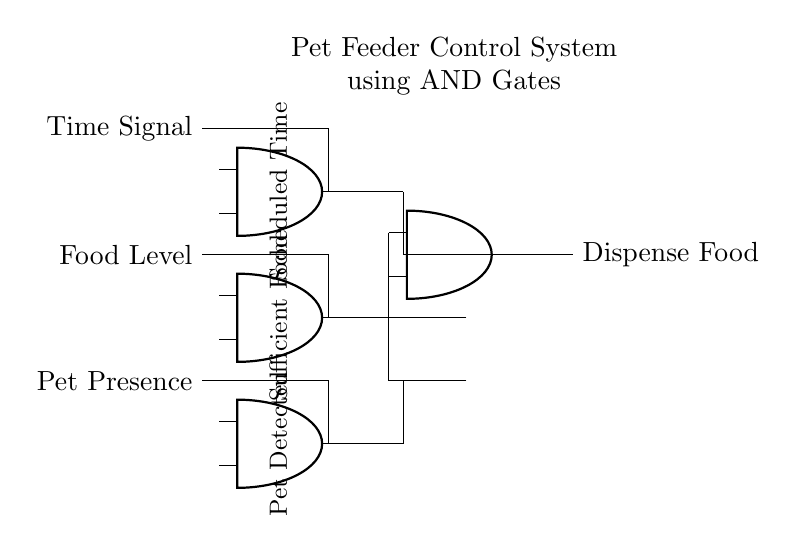What are the inputs to the first AND gate? The inputs to the first AND gate are the "Time Signal" and the "Food Level." It shows that both conditions must be met for the first AND gate to provide an output.
Answer: Time Signal, Food Level What does the final AND gate output trigger? The final AND gate outputs trigger the "Dispense Food" action when all its inputs are satisfied. Each preceding condition must be fulfilled for food to be dispensed.
Answer: Dispense Food How many AND gates are in this circuit? The circuit contains four AND gates: three input gates and one final gate that aggregates their outputs. This setup allows complex conditions to be evaluated.
Answer: Four What three conditions must be true to dispense food? The three conditions that must be true are "Scheduled Time," "Sufficient Food," and "Pet Detected." All conditions must be true to ensure the feeding action occurs.
Answer: Scheduled Time, Sufficient Food, Pet Detected What happens if one of the inputs to the final AND gate is false? If one of the inputs to the final AND gate is false, the output "Dispense Food" will not activate. The logic dictates that all inputs must be true for the dispenser to operate.
Answer: No food dispensed 